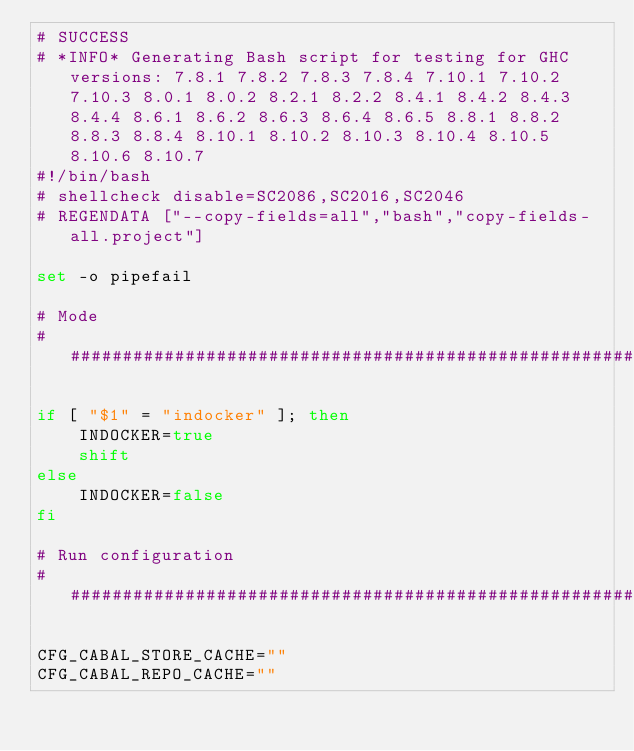Convert code to text. <code><loc_0><loc_0><loc_500><loc_500><_Bash_># SUCCESS
# *INFO* Generating Bash script for testing for GHC versions: 7.8.1 7.8.2 7.8.3 7.8.4 7.10.1 7.10.2 7.10.3 8.0.1 8.0.2 8.2.1 8.2.2 8.4.1 8.4.2 8.4.3 8.4.4 8.6.1 8.6.2 8.6.3 8.6.4 8.6.5 8.8.1 8.8.2 8.8.3 8.8.4 8.10.1 8.10.2 8.10.3 8.10.4 8.10.5 8.10.6 8.10.7
#!/bin/bash
# shellcheck disable=SC2086,SC2016,SC2046
# REGENDATA ["--copy-fields=all","bash","copy-fields-all.project"]

set -o pipefail

# Mode
##############################################################################

if [ "$1" = "indocker" ]; then
    INDOCKER=true
    shift
else
    INDOCKER=false
fi

# Run configuration
##############################################################################

CFG_CABAL_STORE_CACHE=""
CFG_CABAL_REPO_CACHE=""</code> 